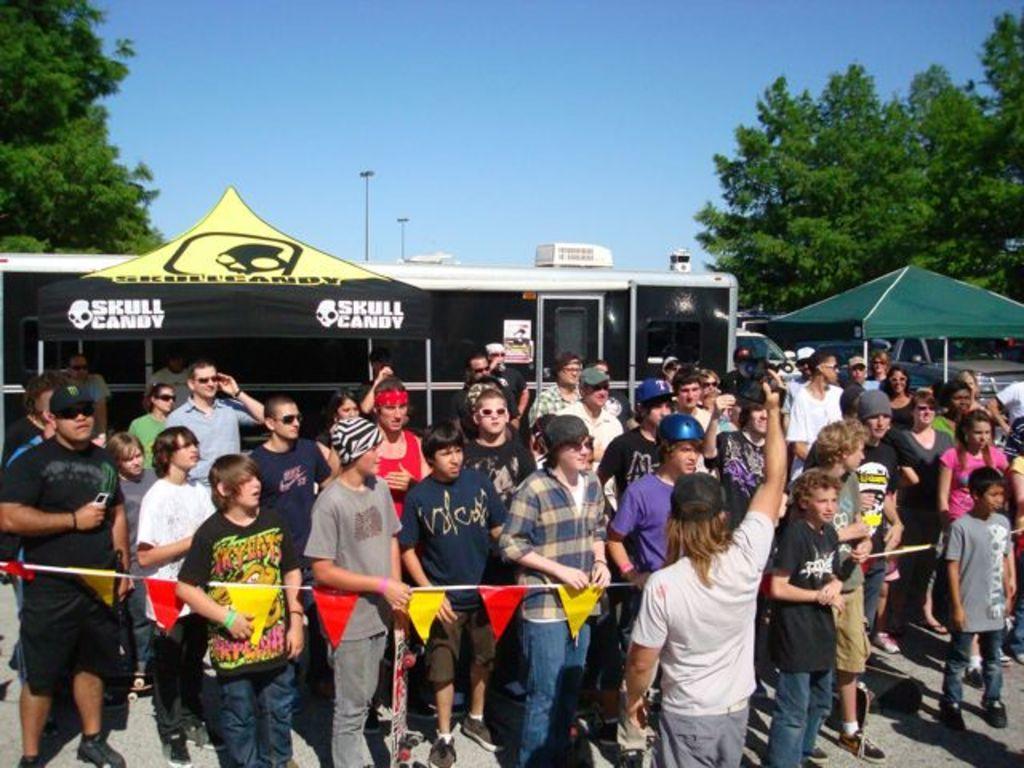Can you describe this image briefly? In the picture we can see a group of people standing near the rope and some colored papers passed to it and in the background, we can see a house with glass windows, and behind we can see some trees, poles, and sky. 